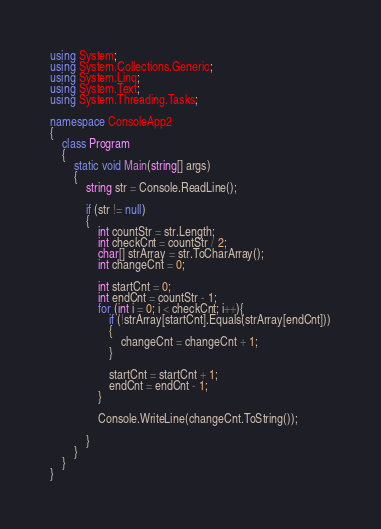Convert code to text. <code><loc_0><loc_0><loc_500><loc_500><_C#_>using System;
using System.Collections.Generic;
using System.Linq;
using System.Text;
using System.Threading.Tasks;

namespace ConsoleApp2
{
    class Program
    {
        static void Main(string[] args)
        {
            string str = Console.ReadLine();

            if (str != null)
            {
                int countStr = str.Length;
                int checkCnt = countStr / 2;
                char[] strArray = str.ToCharArray();
                int changeCnt = 0; 

                int startCnt = 0;
                int endCnt = countStr - 1;
                for (int i = 0; i < checkCnt; i++){
                    if (!strArray[startCnt].Equals(strArray[endCnt]))
                    {
                        changeCnt = changeCnt + 1;
                    }

                    startCnt = startCnt + 1;
                    endCnt = endCnt - 1;
                }

                Console.WriteLine(changeCnt.ToString());
                
            }
        }
    }
}
</code> 